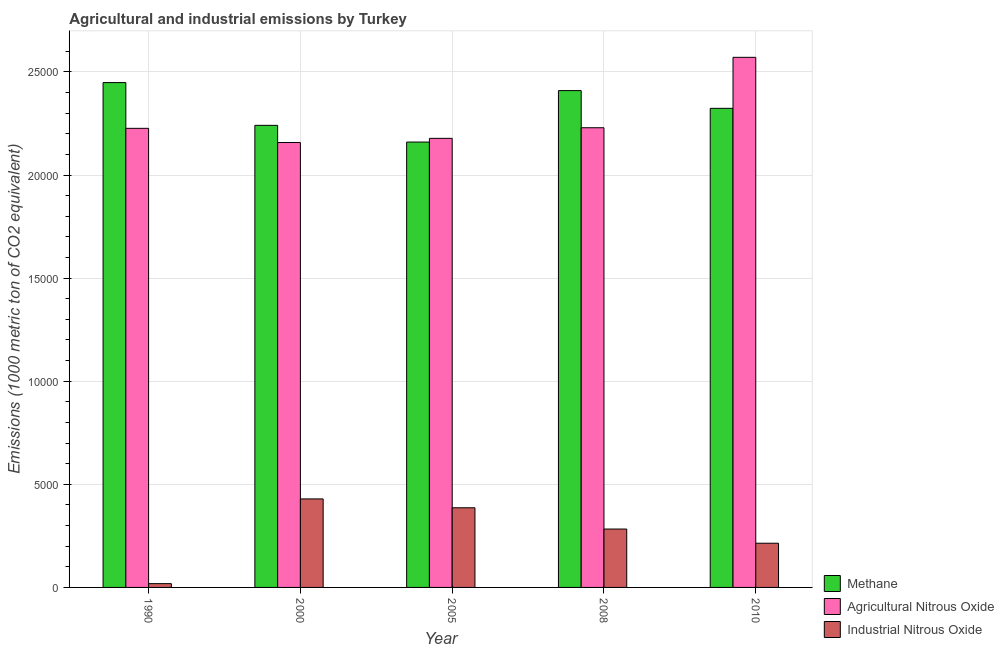Are the number of bars per tick equal to the number of legend labels?
Offer a terse response. Yes. Are the number of bars on each tick of the X-axis equal?
Your answer should be very brief. Yes. What is the label of the 5th group of bars from the left?
Offer a terse response. 2010. In how many cases, is the number of bars for a given year not equal to the number of legend labels?
Provide a succinct answer. 0. What is the amount of agricultural nitrous oxide emissions in 2000?
Your response must be concise. 2.16e+04. Across all years, what is the maximum amount of industrial nitrous oxide emissions?
Ensure brevity in your answer.  4292. Across all years, what is the minimum amount of methane emissions?
Your answer should be compact. 2.16e+04. In which year was the amount of industrial nitrous oxide emissions maximum?
Your answer should be very brief. 2000. In which year was the amount of industrial nitrous oxide emissions minimum?
Make the answer very short. 1990. What is the total amount of agricultural nitrous oxide emissions in the graph?
Ensure brevity in your answer.  1.14e+05. What is the difference between the amount of industrial nitrous oxide emissions in 2005 and that in 2010?
Give a very brief answer. 1718.9. What is the difference between the amount of methane emissions in 2010 and the amount of agricultural nitrous oxide emissions in 2000?
Ensure brevity in your answer.  825. What is the average amount of industrial nitrous oxide emissions per year?
Make the answer very short. 2662.68. In how many years, is the amount of industrial nitrous oxide emissions greater than 19000 metric ton?
Provide a succinct answer. 0. What is the ratio of the amount of industrial nitrous oxide emissions in 1990 to that in 2008?
Give a very brief answer. 0.06. What is the difference between the highest and the second highest amount of industrial nitrous oxide emissions?
Keep it short and to the point. 429.3. What is the difference between the highest and the lowest amount of agricultural nitrous oxide emissions?
Ensure brevity in your answer.  4131.2. In how many years, is the amount of agricultural nitrous oxide emissions greater than the average amount of agricultural nitrous oxide emissions taken over all years?
Your response must be concise. 1. Is the sum of the amount of industrial nitrous oxide emissions in 1990 and 2000 greater than the maximum amount of methane emissions across all years?
Offer a terse response. Yes. What does the 1st bar from the left in 2008 represents?
Offer a very short reply. Methane. What does the 1st bar from the right in 2000 represents?
Give a very brief answer. Industrial Nitrous Oxide. What is the difference between two consecutive major ticks on the Y-axis?
Keep it short and to the point. 5000. Does the graph contain any zero values?
Provide a short and direct response. No. Does the graph contain grids?
Provide a succinct answer. Yes. How many legend labels are there?
Provide a short and direct response. 3. How are the legend labels stacked?
Your answer should be compact. Vertical. What is the title of the graph?
Ensure brevity in your answer.  Agricultural and industrial emissions by Turkey. Does "Domestic" appear as one of the legend labels in the graph?
Provide a succinct answer. No. What is the label or title of the X-axis?
Provide a succinct answer. Year. What is the label or title of the Y-axis?
Your answer should be compact. Emissions (1000 metric ton of CO2 equivalent). What is the Emissions (1000 metric ton of CO2 equivalent) of Methane in 1990?
Offer a terse response. 2.45e+04. What is the Emissions (1000 metric ton of CO2 equivalent) of Agricultural Nitrous Oxide in 1990?
Provide a short and direct response. 2.23e+04. What is the Emissions (1000 metric ton of CO2 equivalent) in Industrial Nitrous Oxide in 1990?
Offer a very short reply. 183.6. What is the Emissions (1000 metric ton of CO2 equivalent) of Methane in 2000?
Give a very brief answer. 2.24e+04. What is the Emissions (1000 metric ton of CO2 equivalent) of Agricultural Nitrous Oxide in 2000?
Keep it short and to the point. 2.16e+04. What is the Emissions (1000 metric ton of CO2 equivalent) of Industrial Nitrous Oxide in 2000?
Ensure brevity in your answer.  4292. What is the Emissions (1000 metric ton of CO2 equivalent) in Methane in 2005?
Offer a terse response. 2.16e+04. What is the Emissions (1000 metric ton of CO2 equivalent) in Agricultural Nitrous Oxide in 2005?
Give a very brief answer. 2.18e+04. What is the Emissions (1000 metric ton of CO2 equivalent) in Industrial Nitrous Oxide in 2005?
Your answer should be very brief. 3862.7. What is the Emissions (1000 metric ton of CO2 equivalent) in Methane in 2008?
Your answer should be compact. 2.41e+04. What is the Emissions (1000 metric ton of CO2 equivalent) of Agricultural Nitrous Oxide in 2008?
Offer a very short reply. 2.23e+04. What is the Emissions (1000 metric ton of CO2 equivalent) in Industrial Nitrous Oxide in 2008?
Your answer should be compact. 2831.3. What is the Emissions (1000 metric ton of CO2 equivalent) of Methane in 2010?
Keep it short and to the point. 2.32e+04. What is the Emissions (1000 metric ton of CO2 equivalent) in Agricultural Nitrous Oxide in 2010?
Make the answer very short. 2.57e+04. What is the Emissions (1000 metric ton of CO2 equivalent) of Industrial Nitrous Oxide in 2010?
Your answer should be compact. 2143.8. Across all years, what is the maximum Emissions (1000 metric ton of CO2 equivalent) in Methane?
Your answer should be very brief. 2.45e+04. Across all years, what is the maximum Emissions (1000 metric ton of CO2 equivalent) in Agricultural Nitrous Oxide?
Keep it short and to the point. 2.57e+04. Across all years, what is the maximum Emissions (1000 metric ton of CO2 equivalent) in Industrial Nitrous Oxide?
Your response must be concise. 4292. Across all years, what is the minimum Emissions (1000 metric ton of CO2 equivalent) in Methane?
Ensure brevity in your answer.  2.16e+04. Across all years, what is the minimum Emissions (1000 metric ton of CO2 equivalent) of Agricultural Nitrous Oxide?
Provide a succinct answer. 2.16e+04. Across all years, what is the minimum Emissions (1000 metric ton of CO2 equivalent) in Industrial Nitrous Oxide?
Make the answer very short. 183.6. What is the total Emissions (1000 metric ton of CO2 equivalent) of Methane in the graph?
Offer a terse response. 1.16e+05. What is the total Emissions (1000 metric ton of CO2 equivalent) in Agricultural Nitrous Oxide in the graph?
Give a very brief answer. 1.14e+05. What is the total Emissions (1000 metric ton of CO2 equivalent) in Industrial Nitrous Oxide in the graph?
Offer a very short reply. 1.33e+04. What is the difference between the Emissions (1000 metric ton of CO2 equivalent) of Methane in 1990 and that in 2000?
Provide a short and direct response. 2073.6. What is the difference between the Emissions (1000 metric ton of CO2 equivalent) in Agricultural Nitrous Oxide in 1990 and that in 2000?
Your answer should be compact. 687.6. What is the difference between the Emissions (1000 metric ton of CO2 equivalent) in Industrial Nitrous Oxide in 1990 and that in 2000?
Your response must be concise. -4108.4. What is the difference between the Emissions (1000 metric ton of CO2 equivalent) of Methane in 1990 and that in 2005?
Offer a very short reply. 2884.1. What is the difference between the Emissions (1000 metric ton of CO2 equivalent) of Agricultural Nitrous Oxide in 1990 and that in 2005?
Your answer should be very brief. 485.1. What is the difference between the Emissions (1000 metric ton of CO2 equivalent) of Industrial Nitrous Oxide in 1990 and that in 2005?
Your answer should be very brief. -3679.1. What is the difference between the Emissions (1000 metric ton of CO2 equivalent) in Methane in 1990 and that in 2008?
Ensure brevity in your answer.  388.8. What is the difference between the Emissions (1000 metric ton of CO2 equivalent) in Agricultural Nitrous Oxide in 1990 and that in 2008?
Your answer should be compact. -28.8. What is the difference between the Emissions (1000 metric ton of CO2 equivalent) of Industrial Nitrous Oxide in 1990 and that in 2008?
Keep it short and to the point. -2647.7. What is the difference between the Emissions (1000 metric ton of CO2 equivalent) in Methane in 1990 and that in 2010?
Your answer should be compact. 1248.6. What is the difference between the Emissions (1000 metric ton of CO2 equivalent) of Agricultural Nitrous Oxide in 1990 and that in 2010?
Provide a short and direct response. -3443.6. What is the difference between the Emissions (1000 metric ton of CO2 equivalent) in Industrial Nitrous Oxide in 1990 and that in 2010?
Make the answer very short. -1960.2. What is the difference between the Emissions (1000 metric ton of CO2 equivalent) of Methane in 2000 and that in 2005?
Provide a short and direct response. 810.5. What is the difference between the Emissions (1000 metric ton of CO2 equivalent) in Agricultural Nitrous Oxide in 2000 and that in 2005?
Provide a short and direct response. -202.5. What is the difference between the Emissions (1000 metric ton of CO2 equivalent) in Industrial Nitrous Oxide in 2000 and that in 2005?
Give a very brief answer. 429.3. What is the difference between the Emissions (1000 metric ton of CO2 equivalent) in Methane in 2000 and that in 2008?
Offer a very short reply. -1684.8. What is the difference between the Emissions (1000 metric ton of CO2 equivalent) in Agricultural Nitrous Oxide in 2000 and that in 2008?
Offer a very short reply. -716.4. What is the difference between the Emissions (1000 metric ton of CO2 equivalent) of Industrial Nitrous Oxide in 2000 and that in 2008?
Provide a short and direct response. 1460.7. What is the difference between the Emissions (1000 metric ton of CO2 equivalent) in Methane in 2000 and that in 2010?
Give a very brief answer. -825. What is the difference between the Emissions (1000 metric ton of CO2 equivalent) in Agricultural Nitrous Oxide in 2000 and that in 2010?
Offer a very short reply. -4131.2. What is the difference between the Emissions (1000 metric ton of CO2 equivalent) of Industrial Nitrous Oxide in 2000 and that in 2010?
Ensure brevity in your answer.  2148.2. What is the difference between the Emissions (1000 metric ton of CO2 equivalent) in Methane in 2005 and that in 2008?
Make the answer very short. -2495.3. What is the difference between the Emissions (1000 metric ton of CO2 equivalent) of Agricultural Nitrous Oxide in 2005 and that in 2008?
Give a very brief answer. -513.9. What is the difference between the Emissions (1000 metric ton of CO2 equivalent) of Industrial Nitrous Oxide in 2005 and that in 2008?
Ensure brevity in your answer.  1031.4. What is the difference between the Emissions (1000 metric ton of CO2 equivalent) of Methane in 2005 and that in 2010?
Your answer should be compact. -1635.5. What is the difference between the Emissions (1000 metric ton of CO2 equivalent) of Agricultural Nitrous Oxide in 2005 and that in 2010?
Ensure brevity in your answer.  -3928.7. What is the difference between the Emissions (1000 metric ton of CO2 equivalent) in Industrial Nitrous Oxide in 2005 and that in 2010?
Provide a succinct answer. 1718.9. What is the difference between the Emissions (1000 metric ton of CO2 equivalent) in Methane in 2008 and that in 2010?
Provide a succinct answer. 859.8. What is the difference between the Emissions (1000 metric ton of CO2 equivalent) in Agricultural Nitrous Oxide in 2008 and that in 2010?
Give a very brief answer. -3414.8. What is the difference between the Emissions (1000 metric ton of CO2 equivalent) in Industrial Nitrous Oxide in 2008 and that in 2010?
Ensure brevity in your answer.  687.5. What is the difference between the Emissions (1000 metric ton of CO2 equivalent) of Methane in 1990 and the Emissions (1000 metric ton of CO2 equivalent) of Agricultural Nitrous Oxide in 2000?
Keep it short and to the point. 2906.3. What is the difference between the Emissions (1000 metric ton of CO2 equivalent) of Methane in 1990 and the Emissions (1000 metric ton of CO2 equivalent) of Industrial Nitrous Oxide in 2000?
Make the answer very short. 2.02e+04. What is the difference between the Emissions (1000 metric ton of CO2 equivalent) in Agricultural Nitrous Oxide in 1990 and the Emissions (1000 metric ton of CO2 equivalent) in Industrial Nitrous Oxide in 2000?
Provide a succinct answer. 1.80e+04. What is the difference between the Emissions (1000 metric ton of CO2 equivalent) in Methane in 1990 and the Emissions (1000 metric ton of CO2 equivalent) in Agricultural Nitrous Oxide in 2005?
Keep it short and to the point. 2703.8. What is the difference between the Emissions (1000 metric ton of CO2 equivalent) in Methane in 1990 and the Emissions (1000 metric ton of CO2 equivalent) in Industrial Nitrous Oxide in 2005?
Give a very brief answer. 2.06e+04. What is the difference between the Emissions (1000 metric ton of CO2 equivalent) of Agricultural Nitrous Oxide in 1990 and the Emissions (1000 metric ton of CO2 equivalent) of Industrial Nitrous Oxide in 2005?
Keep it short and to the point. 1.84e+04. What is the difference between the Emissions (1000 metric ton of CO2 equivalent) in Methane in 1990 and the Emissions (1000 metric ton of CO2 equivalent) in Agricultural Nitrous Oxide in 2008?
Keep it short and to the point. 2189.9. What is the difference between the Emissions (1000 metric ton of CO2 equivalent) in Methane in 1990 and the Emissions (1000 metric ton of CO2 equivalent) in Industrial Nitrous Oxide in 2008?
Provide a succinct answer. 2.17e+04. What is the difference between the Emissions (1000 metric ton of CO2 equivalent) in Agricultural Nitrous Oxide in 1990 and the Emissions (1000 metric ton of CO2 equivalent) in Industrial Nitrous Oxide in 2008?
Provide a short and direct response. 1.94e+04. What is the difference between the Emissions (1000 metric ton of CO2 equivalent) of Methane in 1990 and the Emissions (1000 metric ton of CO2 equivalent) of Agricultural Nitrous Oxide in 2010?
Give a very brief answer. -1224.9. What is the difference between the Emissions (1000 metric ton of CO2 equivalent) of Methane in 1990 and the Emissions (1000 metric ton of CO2 equivalent) of Industrial Nitrous Oxide in 2010?
Make the answer very short. 2.23e+04. What is the difference between the Emissions (1000 metric ton of CO2 equivalent) of Agricultural Nitrous Oxide in 1990 and the Emissions (1000 metric ton of CO2 equivalent) of Industrial Nitrous Oxide in 2010?
Keep it short and to the point. 2.01e+04. What is the difference between the Emissions (1000 metric ton of CO2 equivalent) of Methane in 2000 and the Emissions (1000 metric ton of CO2 equivalent) of Agricultural Nitrous Oxide in 2005?
Make the answer very short. 630.2. What is the difference between the Emissions (1000 metric ton of CO2 equivalent) of Methane in 2000 and the Emissions (1000 metric ton of CO2 equivalent) of Industrial Nitrous Oxide in 2005?
Provide a short and direct response. 1.85e+04. What is the difference between the Emissions (1000 metric ton of CO2 equivalent) of Agricultural Nitrous Oxide in 2000 and the Emissions (1000 metric ton of CO2 equivalent) of Industrial Nitrous Oxide in 2005?
Provide a short and direct response. 1.77e+04. What is the difference between the Emissions (1000 metric ton of CO2 equivalent) of Methane in 2000 and the Emissions (1000 metric ton of CO2 equivalent) of Agricultural Nitrous Oxide in 2008?
Offer a very short reply. 116.3. What is the difference between the Emissions (1000 metric ton of CO2 equivalent) in Methane in 2000 and the Emissions (1000 metric ton of CO2 equivalent) in Industrial Nitrous Oxide in 2008?
Offer a terse response. 1.96e+04. What is the difference between the Emissions (1000 metric ton of CO2 equivalent) in Agricultural Nitrous Oxide in 2000 and the Emissions (1000 metric ton of CO2 equivalent) in Industrial Nitrous Oxide in 2008?
Keep it short and to the point. 1.87e+04. What is the difference between the Emissions (1000 metric ton of CO2 equivalent) of Methane in 2000 and the Emissions (1000 metric ton of CO2 equivalent) of Agricultural Nitrous Oxide in 2010?
Provide a succinct answer. -3298.5. What is the difference between the Emissions (1000 metric ton of CO2 equivalent) in Methane in 2000 and the Emissions (1000 metric ton of CO2 equivalent) in Industrial Nitrous Oxide in 2010?
Give a very brief answer. 2.03e+04. What is the difference between the Emissions (1000 metric ton of CO2 equivalent) in Agricultural Nitrous Oxide in 2000 and the Emissions (1000 metric ton of CO2 equivalent) in Industrial Nitrous Oxide in 2010?
Offer a terse response. 1.94e+04. What is the difference between the Emissions (1000 metric ton of CO2 equivalent) of Methane in 2005 and the Emissions (1000 metric ton of CO2 equivalent) of Agricultural Nitrous Oxide in 2008?
Offer a terse response. -694.2. What is the difference between the Emissions (1000 metric ton of CO2 equivalent) of Methane in 2005 and the Emissions (1000 metric ton of CO2 equivalent) of Industrial Nitrous Oxide in 2008?
Provide a succinct answer. 1.88e+04. What is the difference between the Emissions (1000 metric ton of CO2 equivalent) of Agricultural Nitrous Oxide in 2005 and the Emissions (1000 metric ton of CO2 equivalent) of Industrial Nitrous Oxide in 2008?
Provide a short and direct response. 1.89e+04. What is the difference between the Emissions (1000 metric ton of CO2 equivalent) in Methane in 2005 and the Emissions (1000 metric ton of CO2 equivalent) in Agricultural Nitrous Oxide in 2010?
Provide a succinct answer. -4109. What is the difference between the Emissions (1000 metric ton of CO2 equivalent) of Methane in 2005 and the Emissions (1000 metric ton of CO2 equivalent) of Industrial Nitrous Oxide in 2010?
Offer a very short reply. 1.95e+04. What is the difference between the Emissions (1000 metric ton of CO2 equivalent) of Agricultural Nitrous Oxide in 2005 and the Emissions (1000 metric ton of CO2 equivalent) of Industrial Nitrous Oxide in 2010?
Keep it short and to the point. 1.96e+04. What is the difference between the Emissions (1000 metric ton of CO2 equivalent) of Methane in 2008 and the Emissions (1000 metric ton of CO2 equivalent) of Agricultural Nitrous Oxide in 2010?
Give a very brief answer. -1613.7. What is the difference between the Emissions (1000 metric ton of CO2 equivalent) in Methane in 2008 and the Emissions (1000 metric ton of CO2 equivalent) in Industrial Nitrous Oxide in 2010?
Keep it short and to the point. 2.19e+04. What is the difference between the Emissions (1000 metric ton of CO2 equivalent) of Agricultural Nitrous Oxide in 2008 and the Emissions (1000 metric ton of CO2 equivalent) of Industrial Nitrous Oxide in 2010?
Keep it short and to the point. 2.01e+04. What is the average Emissions (1000 metric ton of CO2 equivalent) in Methane per year?
Your response must be concise. 2.32e+04. What is the average Emissions (1000 metric ton of CO2 equivalent) of Agricultural Nitrous Oxide per year?
Make the answer very short. 2.27e+04. What is the average Emissions (1000 metric ton of CO2 equivalent) of Industrial Nitrous Oxide per year?
Provide a short and direct response. 2662.68. In the year 1990, what is the difference between the Emissions (1000 metric ton of CO2 equivalent) of Methane and Emissions (1000 metric ton of CO2 equivalent) of Agricultural Nitrous Oxide?
Offer a very short reply. 2218.7. In the year 1990, what is the difference between the Emissions (1000 metric ton of CO2 equivalent) in Methane and Emissions (1000 metric ton of CO2 equivalent) in Industrial Nitrous Oxide?
Your answer should be very brief. 2.43e+04. In the year 1990, what is the difference between the Emissions (1000 metric ton of CO2 equivalent) in Agricultural Nitrous Oxide and Emissions (1000 metric ton of CO2 equivalent) in Industrial Nitrous Oxide?
Ensure brevity in your answer.  2.21e+04. In the year 2000, what is the difference between the Emissions (1000 metric ton of CO2 equivalent) in Methane and Emissions (1000 metric ton of CO2 equivalent) in Agricultural Nitrous Oxide?
Keep it short and to the point. 832.7. In the year 2000, what is the difference between the Emissions (1000 metric ton of CO2 equivalent) in Methane and Emissions (1000 metric ton of CO2 equivalent) in Industrial Nitrous Oxide?
Provide a short and direct response. 1.81e+04. In the year 2000, what is the difference between the Emissions (1000 metric ton of CO2 equivalent) of Agricultural Nitrous Oxide and Emissions (1000 metric ton of CO2 equivalent) of Industrial Nitrous Oxide?
Provide a short and direct response. 1.73e+04. In the year 2005, what is the difference between the Emissions (1000 metric ton of CO2 equivalent) of Methane and Emissions (1000 metric ton of CO2 equivalent) of Agricultural Nitrous Oxide?
Provide a succinct answer. -180.3. In the year 2005, what is the difference between the Emissions (1000 metric ton of CO2 equivalent) in Methane and Emissions (1000 metric ton of CO2 equivalent) in Industrial Nitrous Oxide?
Ensure brevity in your answer.  1.77e+04. In the year 2005, what is the difference between the Emissions (1000 metric ton of CO2 equivalent) in Agricultural Nitrous Oxide and Emissions (1000 metric ton of CO2 equivalent) in Industrial Nitrous Oxide?
Give a very brief answer. 1.79e+04. In the year 2008, what is the difference between the Emissions (1000 metric ton of CO2 equivalent) in Methane and Emissions (1000 metric ton of CO2 equivalent) in Agricultural Nitrous Oxide?
Your response must be concise. 1801.1. In the year 2008, what is the difference between the Emissions (1000 metric ton of CO2 equivalent) of Methane and Emissions (1000 metric ton of CO2 equivalent) of Industrial Nitrous Oxide?
Give a very brief answer. 2.13e+04. In the year 2008, what is the difference between the Emissions (1000 metric ton of CO2 equivalent) of Agricultural Nitrous Oxide and Emissions (1000 metric ton of CO2 equivalent) of Industrial Nitrous Oxide?
Offer a very short reply. 1.95e+04. In the year 2010, what is the difference between the Emissions (1000 metric ton of CO2 equivalent) of Methane and Emissions (1000 metric ton of CO2 equivalent) of Agricultural Nitrous Oxide?
Your answer should be compact. -2473.5. In the year 2010, what is the difference between the Emissions (1000 metric ton of CO2 equivalent) of Methane and Emissions (1000 metric ton of CO2 equivalent) of Industrial Nitrous Oxide?
Your response must be concise. 2.11e+04. In the year 2010, what is the difference between the Emissions (1000 metric ton of CO2 equivalent) of Agricultural Nitrous Oxide and Emissions (1000 metric ton of CO2 equivalent) of Industrial Nitrous Oxide?
Your response must be concise. 2.36e+04. What is the ratio of the Emissions (1000 metric ton of CO2 equivalent) in Methane in 1990 to that in 2000?
Offer a terse response. 1.09. What is the ratio of the Emissions (1000 metric ton of CO2 equivalent) in Agricultural Nitrous Oxide in 1990 to that in 2000?
Provide a short and direct response. 1.03. What is the ratio of the Emissions (1000 metric ton of CO2 equivalent) of Industrial Nitrous Oxide in 1990 to that in 2000?
Offer a terse response. 0.04. What is the ratio of the Emissions (1000 metric ton of CO2 equivalent) of Methane in 1990 to that in 2005?
Offer a terse response. 1.13. What is the ratio of the Emissions (1000 metric ton of CO2 equivalent) in Agricultural Nitrous Oxide in 1990 to that in 2005?
Keep it short and to the point. 1.02. What is the ratio of the Emissions (1000 metric ton of CO2 equivalent) of Industrial Nitrous Oxide in 1990 to that in 2005?
Your response must be concise. 0.05. What is the ratio of the Emissions (1000 metric ton of CO2 equivalent) of Methane in 1990 to that in 2008?
Offer a very short reply. 1.02. What is the ratio of the Emissions (1000 metric ton of CO2 equivalent) of Agricultural Nitrous Oxide in 1990 to that in 2008?
Provide a succinct answer. 1. What is the ratio of the Emissions (1000 metric ton of CO2 equivalent) of Industrial Nitrous Oxide in 1990 to that in 2008?
Ensure brevity in your answer.  0.06. What is the ratio of the Emissions (1000 metric ton of CO2 equivalent) of Methane in 1990 to that in 2010?
Your response must be concise. 1.05. What is the ratio of the Emissions (1000 metric ton of CO2 equivalent) of Agricultural Nitrous Oxide in 1990 to that in 2010?
Keep it short and to the point. 0.87. What is the ratio of the Emissions (1000 metric ton of CO2 equivalent) in Industrial Nitrous Oxide in 1990 to that in 2010?
Offer a terse response. 0.09. What is the ratio of the Emissions (1000 metric ton of CO2 equivalent) in Methane in 2000 to that in 2005?
Provide a short and direct response. 1.04. What is the ratio of the Emissions (1000 metric ton of CO2 equivalent) of Agricultural Nitrous Oxide in 2000 to that in 2005?
Your response must be concise. 0.99. What is the ratio of the Emissions (1000 metric ton of CO2 equivalent) in Methane in 2000 to that in 2008?
Provide a succinct answer. 0.93. What is the ratio of the Emissions (1000 metric ton of CO2 equivalent) of Agricultural Nitrous Oxide in 2000 to that in 2008?
Your answer should be compact. 0.97. What is the ratio of the Emissions (1000 metric ton of CO2 equivalent) in Industrial Nitrous Oxide in 2000 to that in 2008?
Keep it short and to the point. 1.52. What is the ratio of the Emissions (1000 metric ton of CO2 equivalent) in Methane in 2000 to that in 2010?
Your response must be concise. 0.96. What is the ratio of the Emissions (1000 metric ton of CO2 equivalent) of Agricultural Nitrous Oxide in 2000 to that in 2010?
Your answer should be very brief. 0.84. What is the ratio of the Emissions (1000 metric ton of CO2 equivalent) of Industrial Nitrous Oxide in 2000 to that in 2010?
Make the answer very short. 2. What is the ratio of the Emissions (1000 metric ton of CO2 equivalent) of Methane in 2005 to that in 2008?
Offer a terse response. 0.9. What is the ratio of the Emissions (1000 metric ton of CO2 equivalent) in Agricultural Nitrous Oxide in 2005 to that in 2008?
Offer a terse response. 0.98. What is the ratio of the Emissions (1000 metric ton of CO2 equivalent) in Industrial Nitrous Oxide in 2005 to that in 2008?
Your answer should be very brief. 1.36. What is the ratio of the Emissions (1000 metric ton of CO2 equivalent) of Methane in 2005 to that in 2010?
Your answer should be very brief. 0.93. What is the ratio of the Emissions (1000 metric ton of CO2 equivalent) in Agricultural Nitrous Oxide in 2005 to that in 2010?
Your answer should be compact. 0.85. What is the ratio of the Emissions (1000 metric ton of CO2 equivalent) in Industrial Nitrous Oxide in 2005 to that in 2010?
Provide a short and direct response. 1.8. What is the ratio of the Emissions (1000 metric ton of CO2 equivalent) of Methane in 2008 to that in 2010?
Provide a succinct answer. 1.04. What is the ratio of the Emissions (1000 metric ton of CO2 equivalent) of Agricultural Nitrous Oxide in 2008 to that in 2010?
Provide a succinct answer. 0.87. What is the ratio of the Emissions (1000 metric ton of CO2 equivalent) of Industrial Nitrous Oxide in 2008 to that in 2010?
Make the answer very short. 1.32. What is the difference between the highest and the second highest Emissions (1000 metric ton of CO2 equivalent) of Methane?
Give a very brief answer. 388.8. What is the difference between the highest and the second highest Emissions (1000 metric ton of CO2 equivalent) in Agricultural Nitrous Oxide?
Keep it short and to the point. 3414.8. What is the difference between the highest and the second highest Emissions (1000 metric ton of CO2 equivalent) in Industrial Nitrous Oxide?
Ensure brevity in your answer.  429.3. What is the difference between the highest and the lowest Emissions (1000 metric ton of CO2 equivalent) in Methane?
Offer a terse response. 2884.1. What is the difference between the highest and the lowest Emissions (1000 metric ton of CO2 equivalent) of Agricultural Nitrous Oxide?
Your answer should be very brief. 4131.2. What is the difference between the highest and the lowest Emissions (1000 metric ton of CO2 equivalent) in Industrial Nitrous Oxide?
Make the answer very short. 4108.4. 